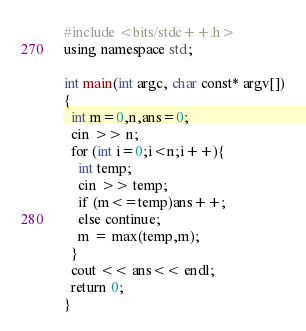Convert code to text. <code><loc_0><loc_0><loc_500><loc_500><_C++_>#include <bits/stdc++.h>
using namespace std;

int main(int argc, char const* argv[])
{
  int m=0,n,ans=0;
  cin >> n;
  for (int i=0;i<n;i++){
    int temp;
    cin >> temp;
    if (m<=temp)ans++;
    else continue;
    m = max(temp,m);
  }
  cout << ans<< endl;
  return 0;
}
</code> 